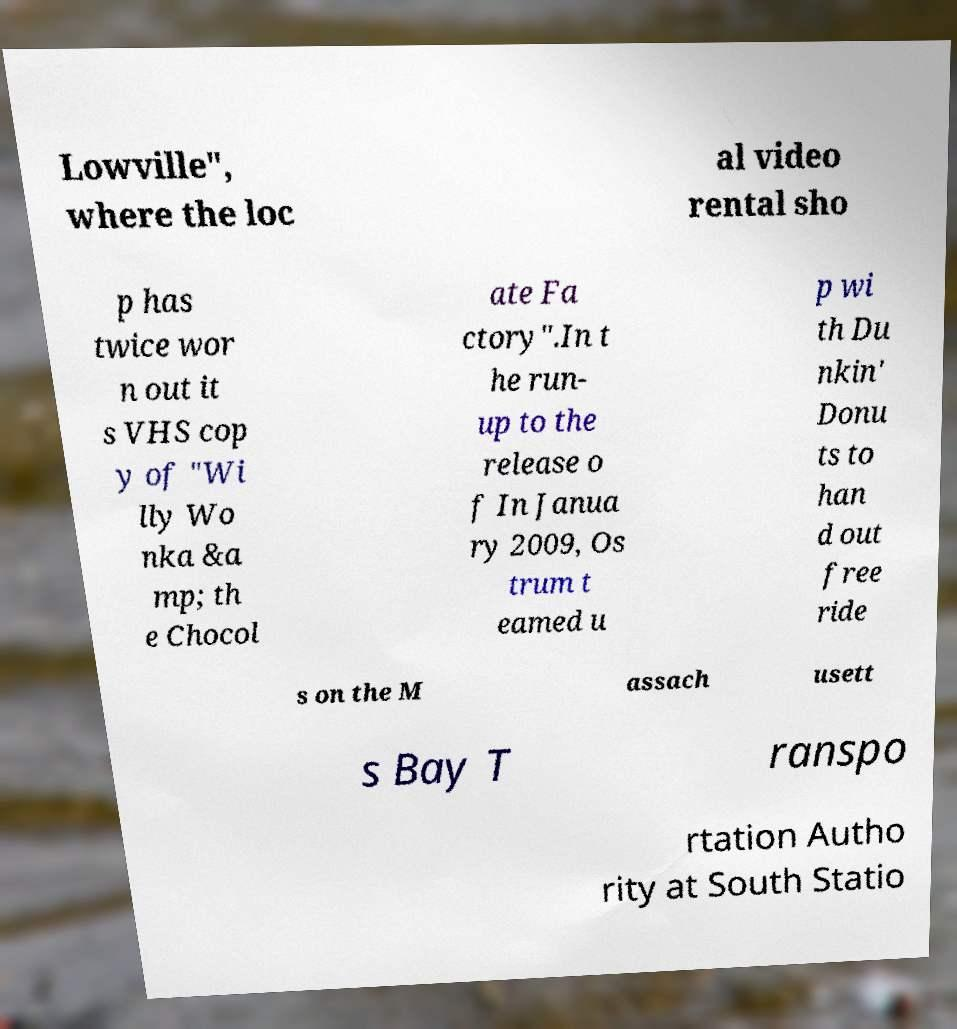What messages or text are displayed in this image? I need them in a readable, typed format. Lowville", where the loc al video rental sho p has twice wor n out it s VHS cop y of "Wi lly Wo nka &a mp; th e Chocol ate Fa ctory".In t he run- up to the release o f In Janua ry 2009, Os trum t eamed u p wi th Du nkin' Donu ts to han d out free ride s on the M assach usett s Bay T ranspo rtation Autho rity at South Statio 